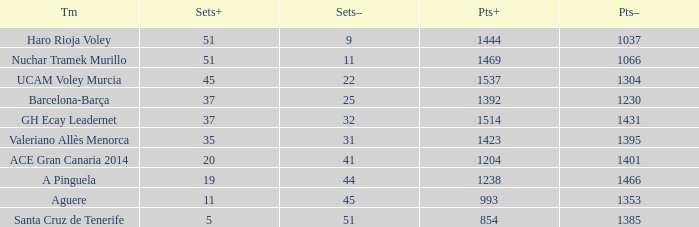What is the total number of Points- when the Sets- is larger than 51? 0.0. 